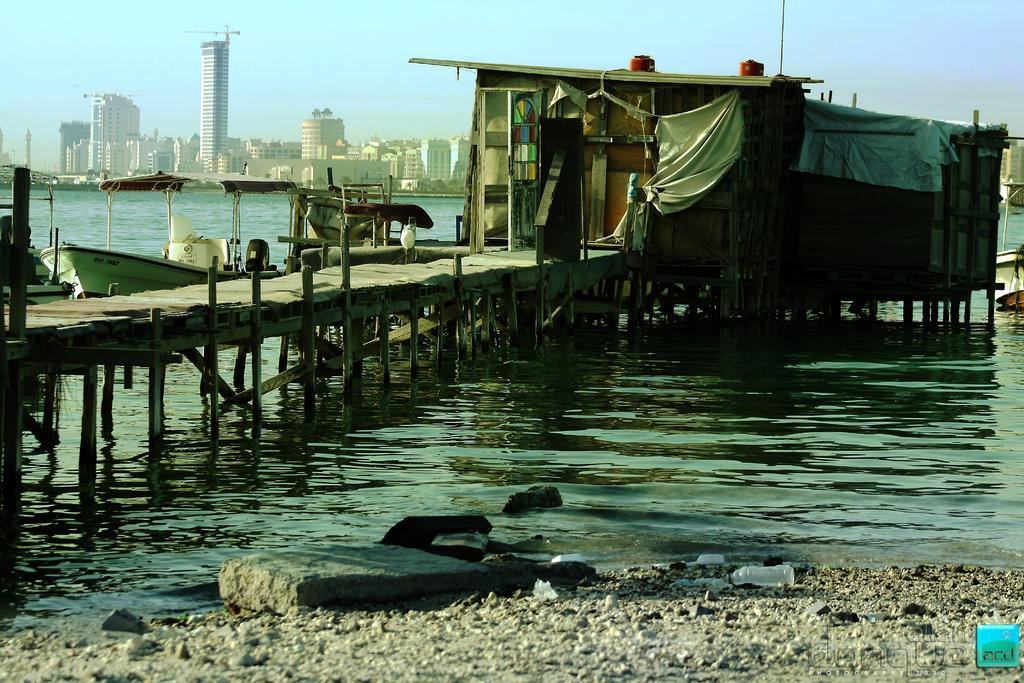What is located in the water in the image? There is a shed in the water in the image. What type of environment is depicted in the image? There is water visible in the image, suggesting a water-based environment. What other structures can be seen in the image? There are buildings in the image. What type of wool is being used to power the shed in the image? There is no wool or power source mentioned in the image; it simply shows a shed in the water. 